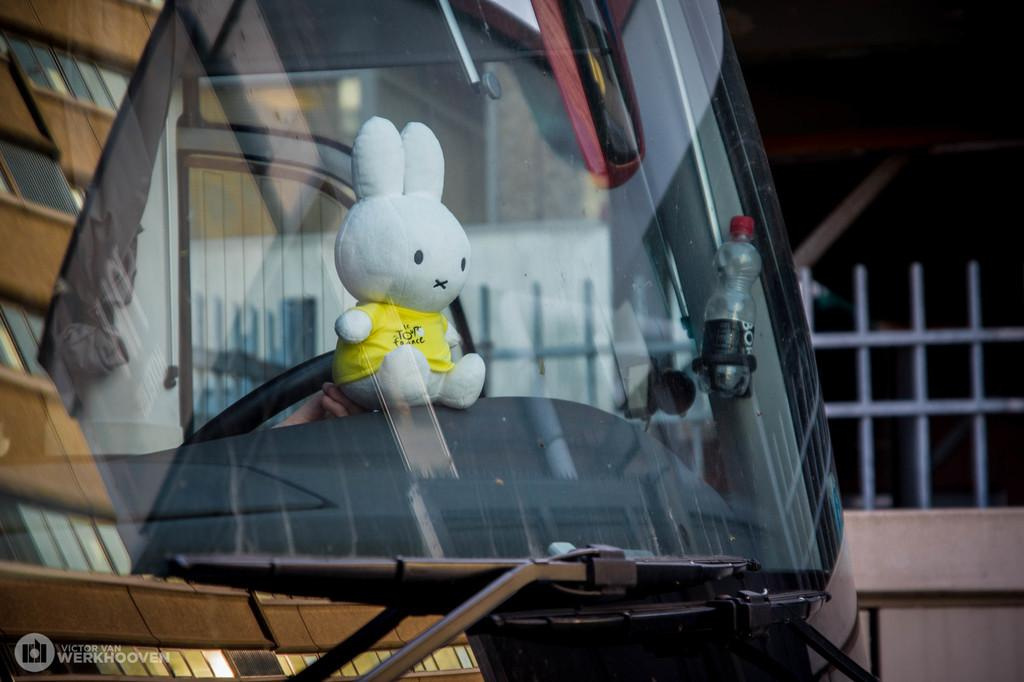What type of object can be seen inside the vehicle in the image? There is a white-colored soft toy in the vehicle. What is attached to the glass of the vehicle? There is a bottle attached to the glass of the vehicle. What can be seen in the background of the image? There is a fence visible in the background of the image. In which direction is the vehicle facing in the image? The direction the vehicle is facing cannot be determined from the image. How many rings are visible on the soft toy in the image? There are no rings visible on the soft toy in the image. 